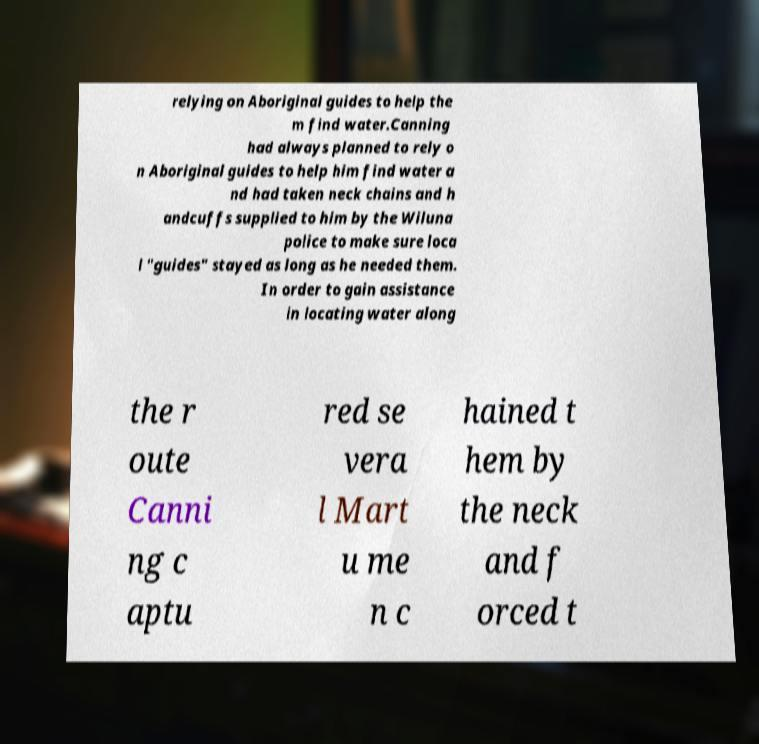There's text embedded in this image that I need extracted. Can you transcribe it verbatim? relying on Aboriginal guides to help the m find water.Canning had always planned to rely o n Aboriginal guides to help him find water a nd had taken neck chains and h andcuffs supplied to him by the Wiluna police to make sure loca l "guides" stayed as long as he needed them. In order to gain assistance in locating water along the r oute Canni ng c aptu red se vera l Mart u me n c hained t hem by the neck and f orced t 